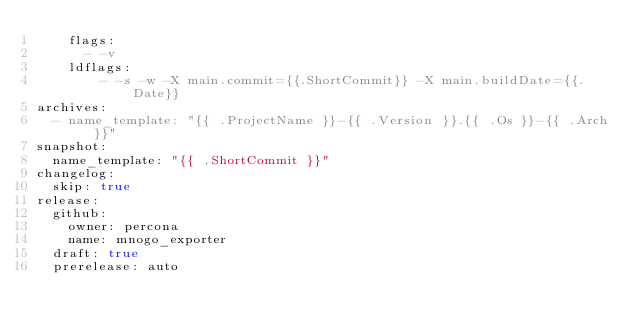<code> <loc_0><loc_0><loc_500><loc_500><_YAML_>    flags:
      - -v
    ldflags: 
        - -s -w -X main.commit={{.ShortCommit}} -X main.buildDate={{.Date}}
archives:
  - name_template: "{{ .ProjectName }}-{{ .Version }}.{{ .Os }}-{{ .Arch }}"
snapshot:
  name_template: "{{ .ShortCommit }}"
changelog:
  skip: true
release:
  github:
    owner: percona
    name: mnogo_exporter
  draft: true
  prerelease: auto
</code> 